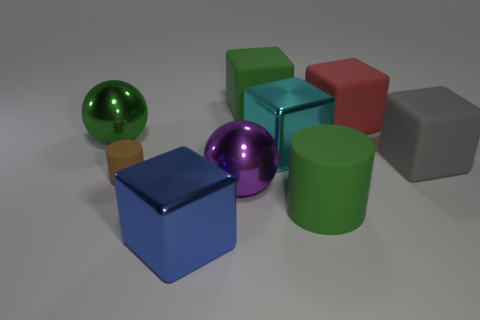Subtract all large blue cubes. How many cubes are left? 4 Subtract all cyan blocks. How many blocks are left? 4 Subtract 1 blocks. How many blocks are left? 4 Subtract all brown cubes. Subtract all red balls. How many cubes are left? 5 Add 1 big rubber things. How many objects exist? 10 Subtract all spheres. How many objects are left? 7 Subtract 0 blue cylinders. How many objects are left? 9 Subtract all shiny cubes. Subtract all large matte blocks. How many objects are left? 4 Add 4 big metal cubes. How many big metal cubes are left? 6 Add 5 big purple metal objects. How many big purple metal objects exist? 6 